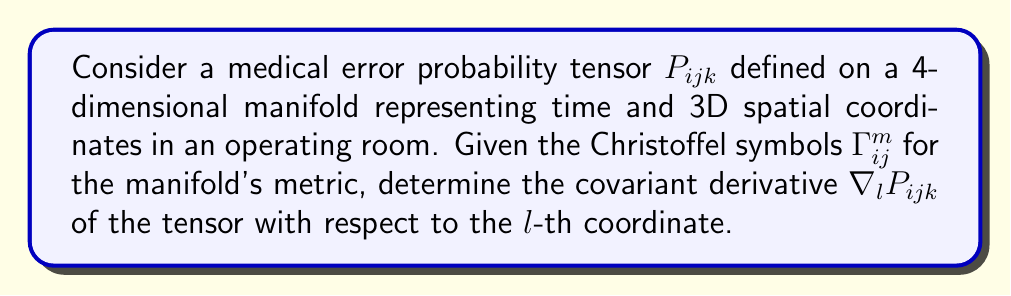Could you help me with this problem? To find the covariant derivative of the medical error probability tensor $P_{ijk}$, we follow these steps:

1. Recall the formula for the covariant derivative of a rank-3 tensor:

   $$\nabla_l P_{ijk} = \partial_l P_{ijk} + \Gamma^m_{li}P_{mjk} + \Gamma^m_{lj}P_{imk} + \Gamma^m_{lk}P_{ijm} - \Gamma^m_{li}P_{mjk}$$

2. Break down the components:
   a) $\partial_l P_{ijk}$ is the partial derivative of $P_{ijk}$ with respect to the $l$-th coordinate.
   b) $\Gamma^m_{li}P_{mjk}$, $\Gamma^m_{lj}P_{imk}$, and $\Gamma^m_{lk}P_{ijm}$ are the connection terms for each index.
   c) $\Gamma^m_{li}P_{mjk}$ is the correction term due to the coordinate system's curvature.

3. The covariant derivative accounts for how the tensor changes as you move in the $l$ direction, considering both the intrinsic change of the tensor and the change due to the coordinate system's geometry.

4. In the context of medical error probability, this covariant derivative represents how the probability of errors changes as you move through time and space in the operating room, taking into account the non-Euclidean nature of the spacetime manifold.

5. The final expression for the covariant derivative is:

   $$\nabla_l P_{ijk} = \partial_l P_{ijk} + \Gamma^m_{li}P_{mjk} + \Gamma^m_{lj}P_{imk} + \Gamma^m_{lk}P_{ijm} - \Gamma^m_{li}P_{mjk}$$

   This expression fully describes how the medical error probability tensor changes, incorporating both its intrinsic variation and the effects of the manifold's geometry.
Answer: $$\nabla_l P_{ijk} = \partial_l P_{ijk} + \Gamma^m_{li}P_{mjk} + \Gamma^m_{lj}P_{imk} + \Gamma^m_{lk}P_{ijm} - \Gamma^m_{li}P_{mjk}$$ 